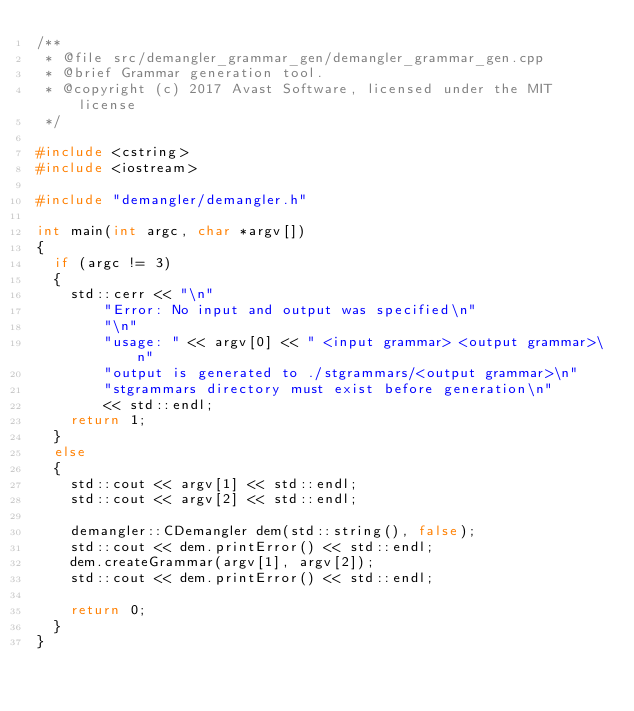Convert code to text. <code><loc_0><loc_0><loc_500><loc_500><_C++_>/**
 * @file src/demangler_grammar_gen/demangler_grammar_gen.cpp
 * @brief Grammar generation tool.
 * @copyright (c) 2017 Avast Software, licensed under the MIT license
 */

#include <cstring>
#include <iostream>

#include "demangler/demangler.h"

int main(int argc, char *argv[])
{
	if (argc != 3)
	{
		std::cerr << "\n"
				"Error: No input and output was specified\n"
				"\n"
				"usage: " << argv[0] << " <input grammar> <output grammar>\n"
				"output is generated to ./stgrammars/<output grammar>\n"
				"stgrammars directory must exist before generation\n"
				<< std::endl;
		return 1;
	}
	else
	{
		std::cout << argv[1] << std::endl;
		std::cout << argv[2] << std::endl;

		demangler::CDemangler dem(std::string(), false);
		std::cout << dem.printError() << std::endl;
		dem.createGrammar(argv[1], argv[2]);
		std::cout << dem.printError() << std::endl;

		return 0;
	}
}
</code> 